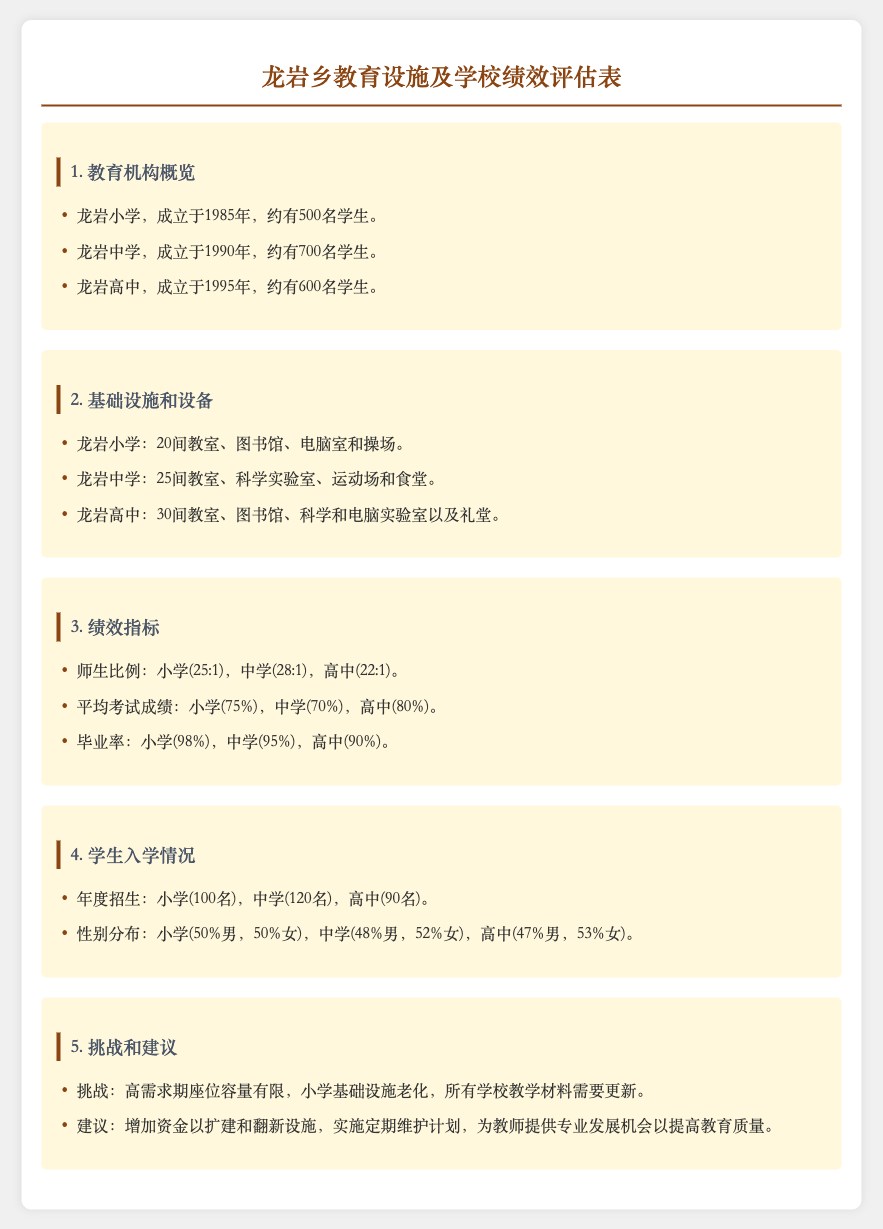What year was Longyan Elementary School established? The document states that Longyan Elementary School was established in 1985.
Answer: 1985 How many students are enrolled in Longyan High School? According to the document, Longyan High School has approximately 600 students enrolled.
Answer: 600 What is the average exam score for Longyan Middle School? The document indicates that the average exam score for Longyan Middle School is 70%.
Answer: 70% What is the teacher-student ratio in Longyan Primary School? The document mentions that the teacher-student ratio in Longyan Primary School is 25:1.
Answer: 25:1 What is the graduation rate for Longyan High School? The document provides that the graduation rate for Longyan High School is 90%.
Answer: 90% What are the main challenges faced by the schools in Longyan Township? The document lists challenges such as limited seating capacity during high-demand periods and outdated facilities in elementary schools.
Answer: High demand seat capacity and outdated facilities How many classrooms does Longyan Middle School have? The document states that Longyan Middle School has 25 classrooms.
Answer: 25 What percentage of Longyan High School students are male? The document reveals that 47% of Longyan High School students are male.
Answer: 47% What suggestion is made for improving educational quality? The document suggests providing professional development opportunities for teachers to improve educational quality.
Answer: Professional development opportunities for teachers 